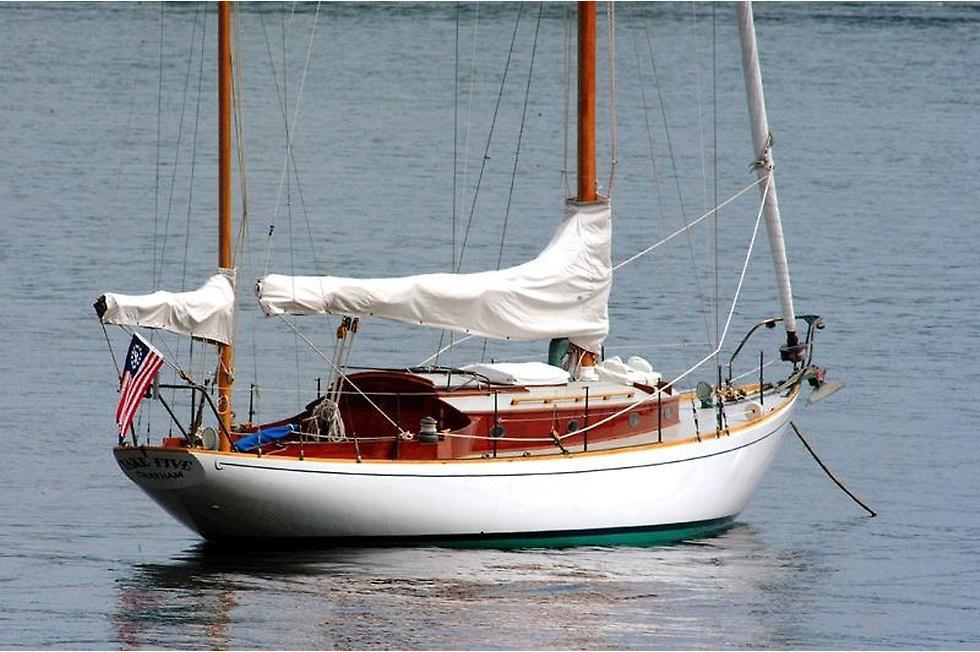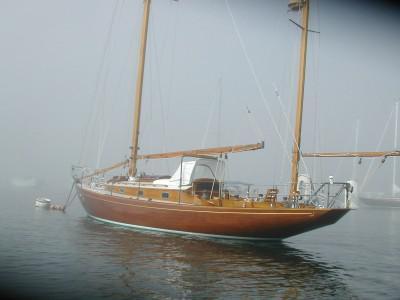The first image is the image on the left, the second image is the image on the right. Examine the images to the left and right. Is the description "People are sailing." accurate? Answer yes or no. No. The first image is the image on the left, the second image is the image on the right. Evaluate the accuracy of this statement regarding the images: "The left and right image contains the same number of  sailboats in the water.". Is it true? Answer yes or no. Yes. 